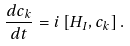<formula> <loc_0><loc_0><loc_500><loc_500>\frac { d c _ { k } } { d t } = i \left [ H _ { I } , c _ { k } \right ] .</formula> 